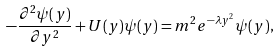Convert formula to latex. <formula><loc_0><loc_0><loc_500><loc_500>- \frac { \partial ^ { 2 } \psi ( y ) } { \partial y ^ { 2 } } + U ( y ) \psi ( y ) = m ^ { 2 } e ^ { - \lambda y ^ { 2 } } \psi ( y ) ,</formula> 